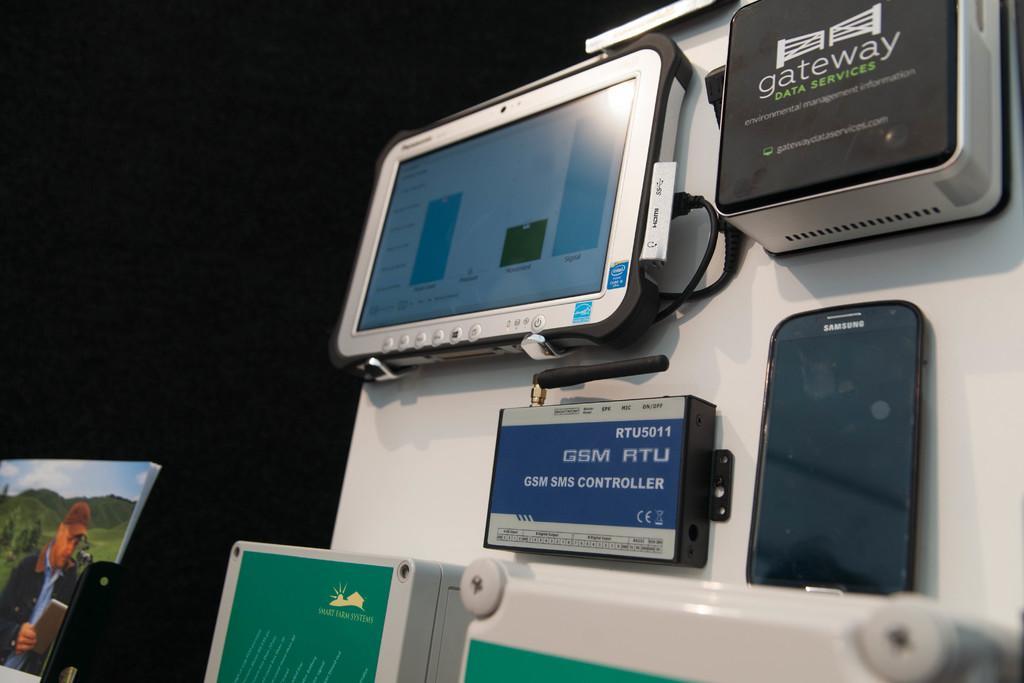Could you give a brief overview of what you see in this image? In this picture there is a mobile phone and devices towards the right. Towards the left corner there is a person on the screen. 